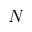Convert formula to latex. <formula><loc_0><loc_0><loc_500><loc_500>N</formula> 